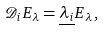<formula> <loc_0><loc_0><loc_500><loc_500>{ \mathcal { D } } _ { i } E _ { \lambda } = \underline { \lambda _ { i } } E _ { \lambda } \, ,</formula> 